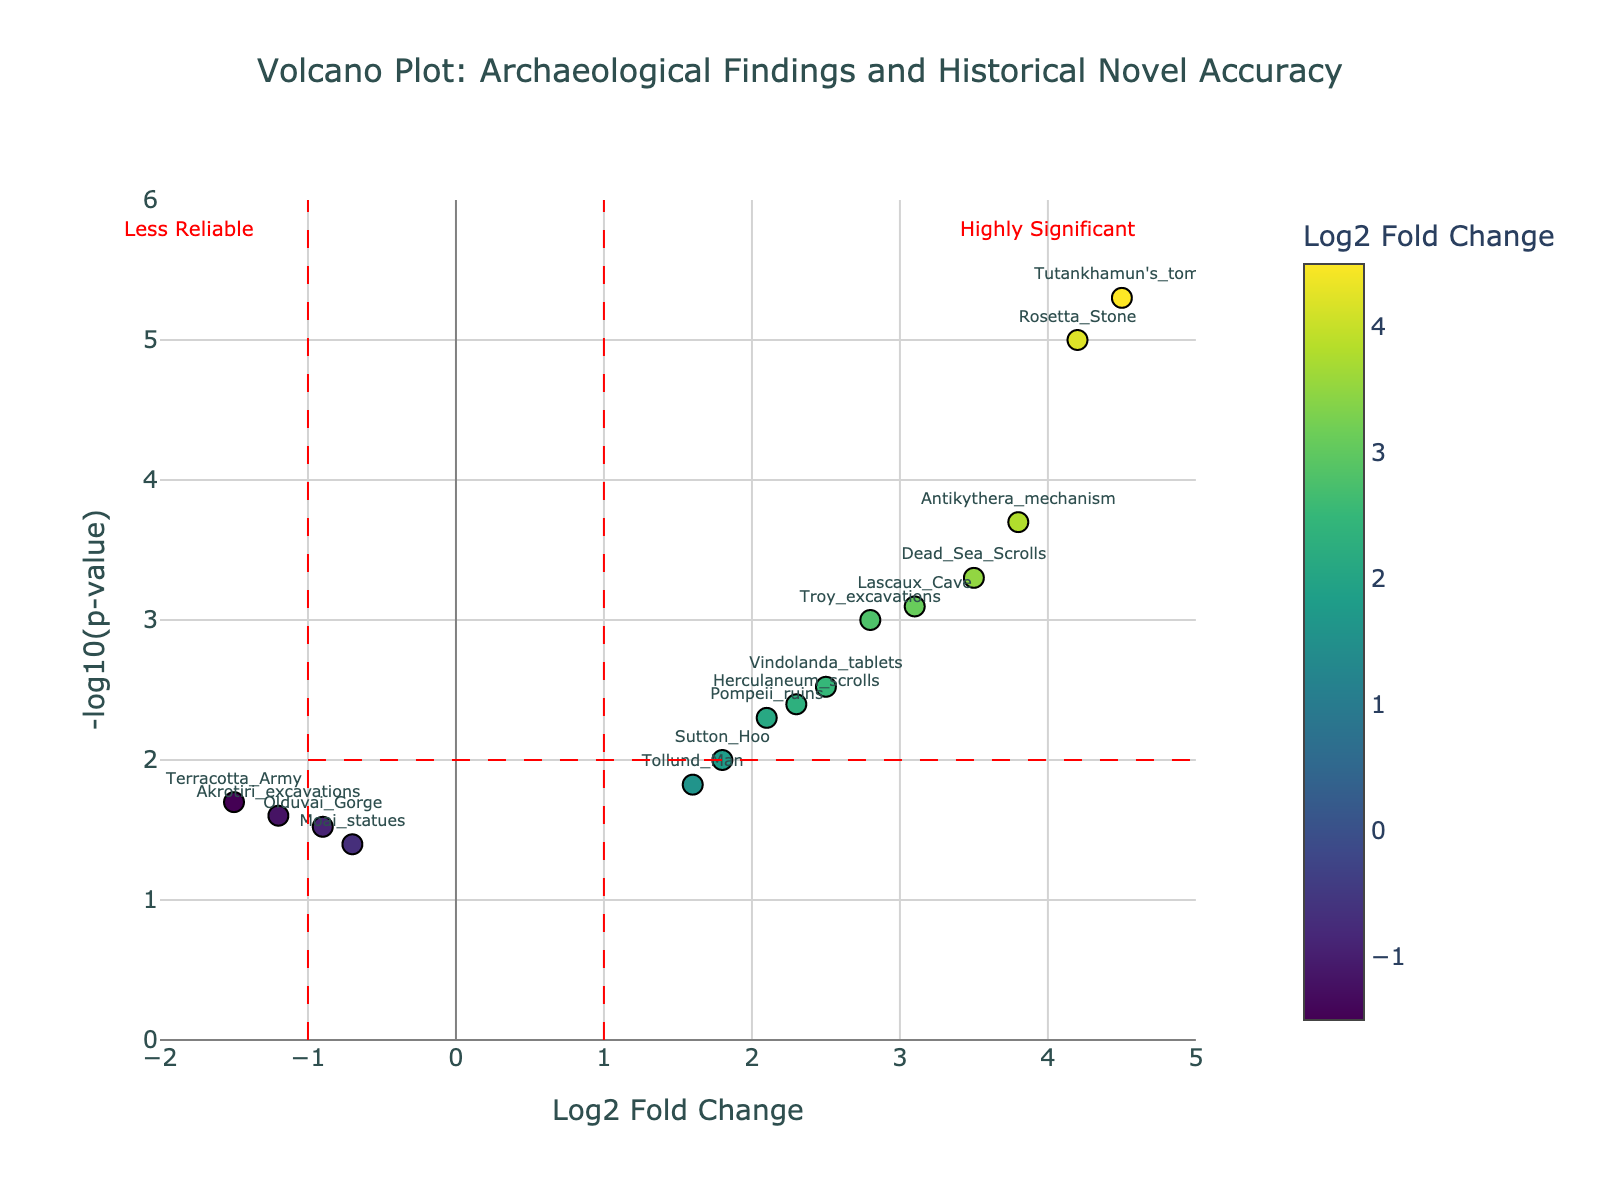What is the title of the plot? The title of the plot is found at the top center of the figure. It reads "Volcano Plot: Archaeological Findings and Historical Novel Accuracy".
Answer: Volcano Plot: Archaeological Findings and Historical Novel Accuracy What is represented on the x-axis? The x-axis is labeled "Log2 Fold Change", indicating it represents the logarithm to the base 2 of the fold change of the archaeological findings.
Answer: Log2 Fold Change How many data points are in the plot? Each dot represents a data point, and we can count a total of 15 labeled points such as "Troy_excavations", "Dead Sea Scrolls", and others.
Answer: 15 Which data point has the highest -log10(p-value)? The highest -log10(p-value) is the point at the top of the plot. This is "Tutankhamun's_tomb" with a -log10(p-value) value of 5.301.
Answer: Tutankhamun's_tomb What does the color scale represent in the plot? The color scale bar on the right side of the plot shows that it represents "Log2 Fold Change" values. The darker shades indicate smaller or negative values, and lighter shades indicate higher values.
Answer: Log2 Fold Change Which archaeological finding has the most significant p-value? The most significant p-value corresponds to the highest -log10(p-value) on the y-axis. "Tutankhamun's_tomb" has the highest -log10(p-value), implying the most significant p-value of 0.000005.
Answer: Tutankhamun's_tomb Which archaeological findings are considered less reliable based on the plot? Data points considered less reliable are those in the "Less Reliable" section marked on the plot on the left. These are "Olduvai_Gorge", "Moai_statues", and "Akrotiri_excavations" which have negative or small Log2 Fold Change and fall to the left of the vertical significance line at Log2 Fold Change = -1.
Answer: Olduvai_Gorge, Moai_statues, Akrotiri_excavations How many archaeological findings have a -log10(p-value) greater than 3? To determine this, we look at all data points above the y-value 3. These are "Tutankhamun's_tomb", "Rosetta_Stone", "Antikythera_mechanism", "Dead_Sea_Scrolls", and "Lascaux_Cave". There are 5 such findings.
Answer: 5 Compare the Log2 Fold Change of “Troy_excavations” and “Pompeii_ruins”. Which is higher? "Troy_excavations" has a Log2 Fold Change of 2.8 while "Pompeii_ruins" has a Log2 Fold Change of 2.1. Thus, "Troy_excavations" has a higher Log2 Fold Change.
Answer: Troy_excavations 